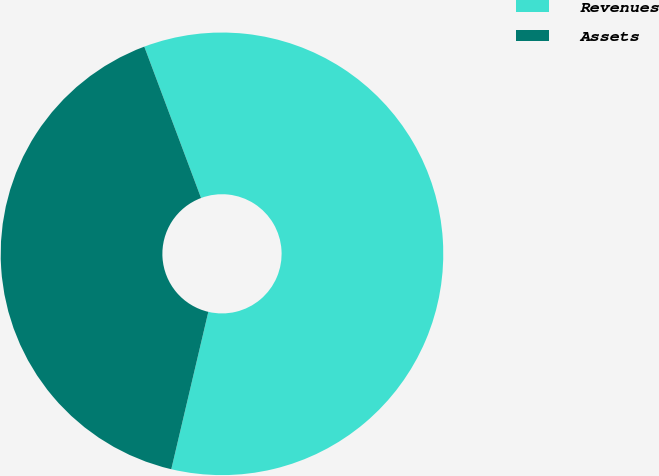Convert chart. <chart><loc_0><loc_0><loc_500><loc_500><pie_chart><fcel>Revenues<fcel>Assets<nl><fcel>59.39%<fcel>40.61%<nl></chart> 